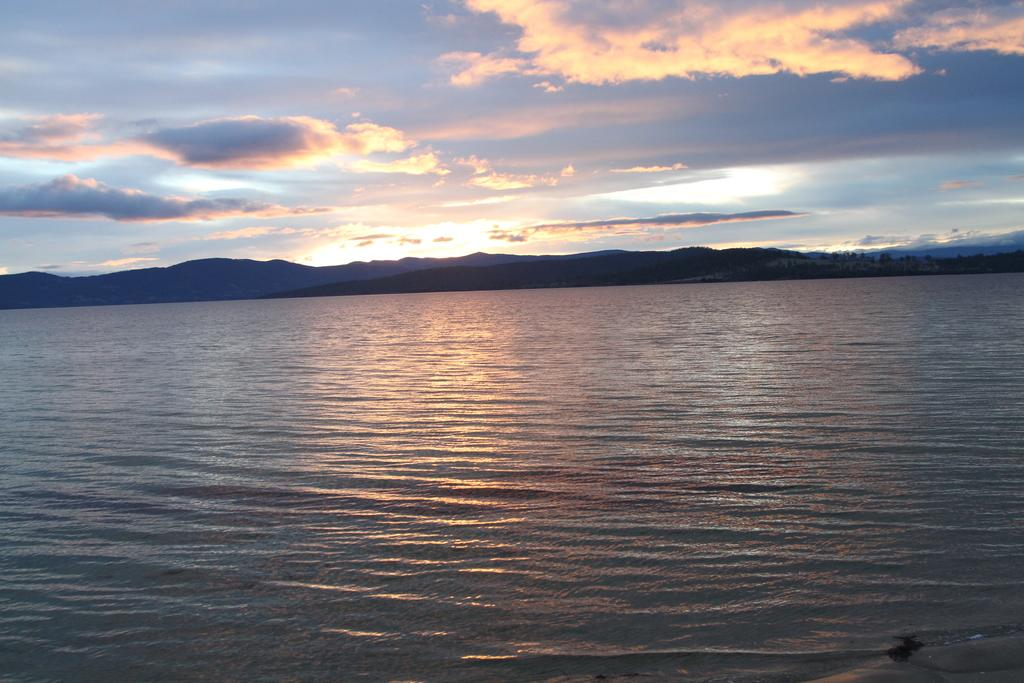What is present in the image that is not solid? There is water in the image. What type of natural formation can be seen in the background of the image? There are mountains visible in the background of the image. What is the color of the sky in the image? The sky is blue and white in color. What type of insect can be seen flying near the mountains in the image? There are no insects visible in the image; it only features water, mountains, and the sky. What type of flesh can be seen in the image? There is no flesh present in the image. 